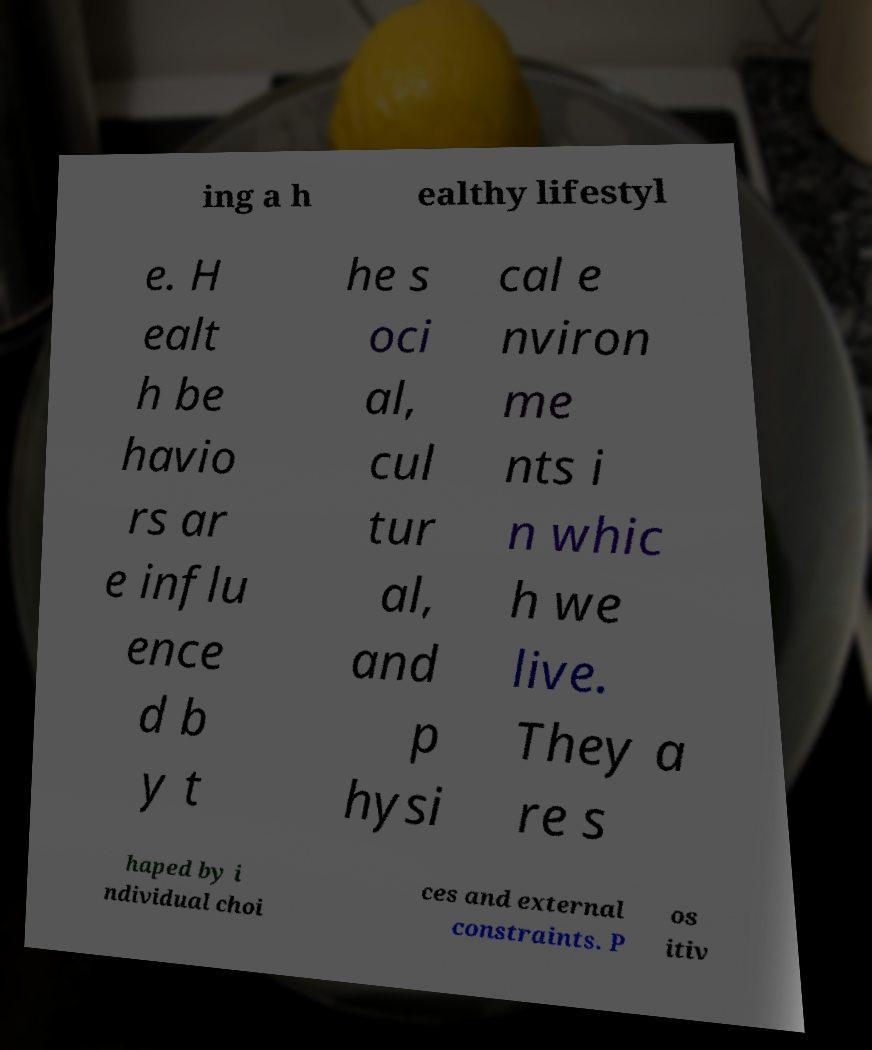Please identify and transcribe the text found in this image. ing a h ealthy lifestyl e. H ealt h be havio rs ar e influ ence d b y t he s oci al, cul tur al, and p hysi cal e nviron me nts i n whic h we live. They a re s haped by i ndividual choi ces and external constraints. P os itiv 